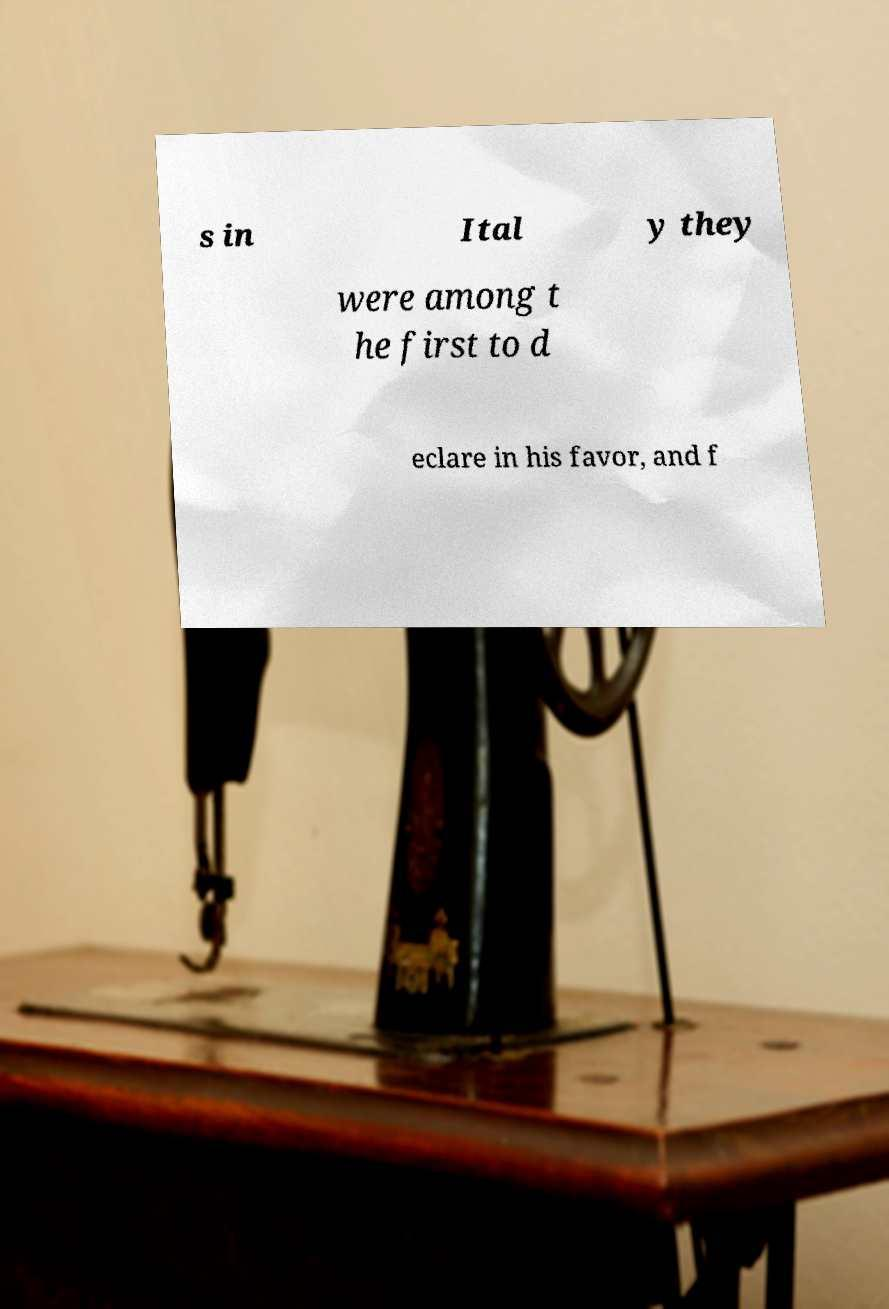For documentation purposes, I need the text within this image transcribed. Could you provide that? s in Ital y they were among t he first to d eclare in his favor, and f 